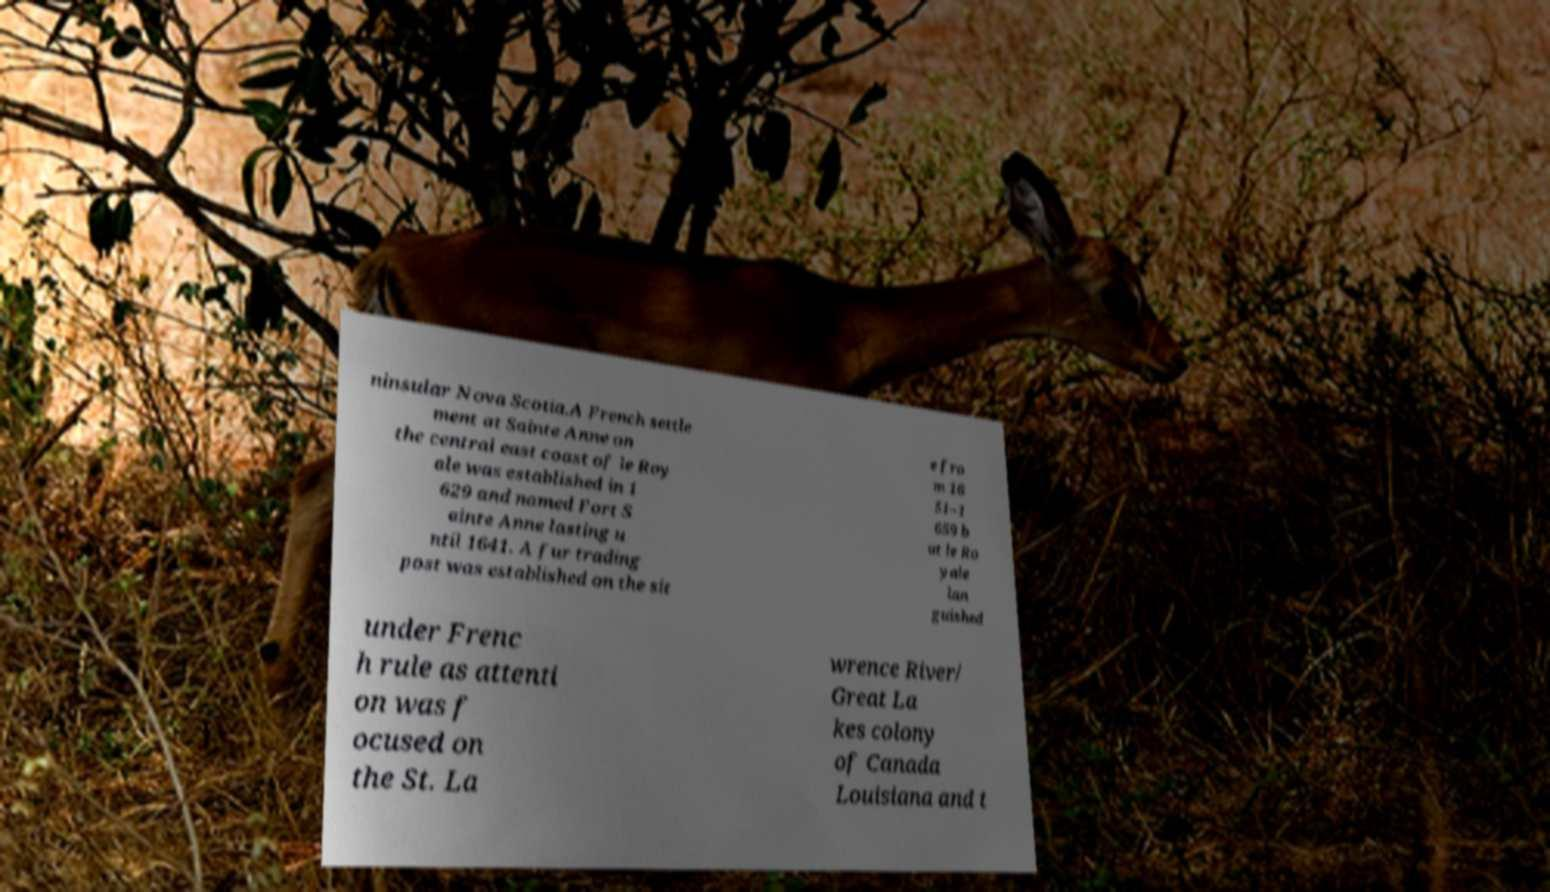Please identify and transcribe the text found in this image. ninsular Nova Scotia.A French settle ment at Sainte Anne on the central east coast of le Roy ale was established in 1 629 and named Fort S ainte Anne lasting u ntil 1641. A fur trading post was established on the sit e fro m 16 51–1 659 b ut le Ro yale lan guished under Frenc h rule as attenti on was f ocused on the St. La wrence River/ Great La kes colony of Canada Louisiana and t 